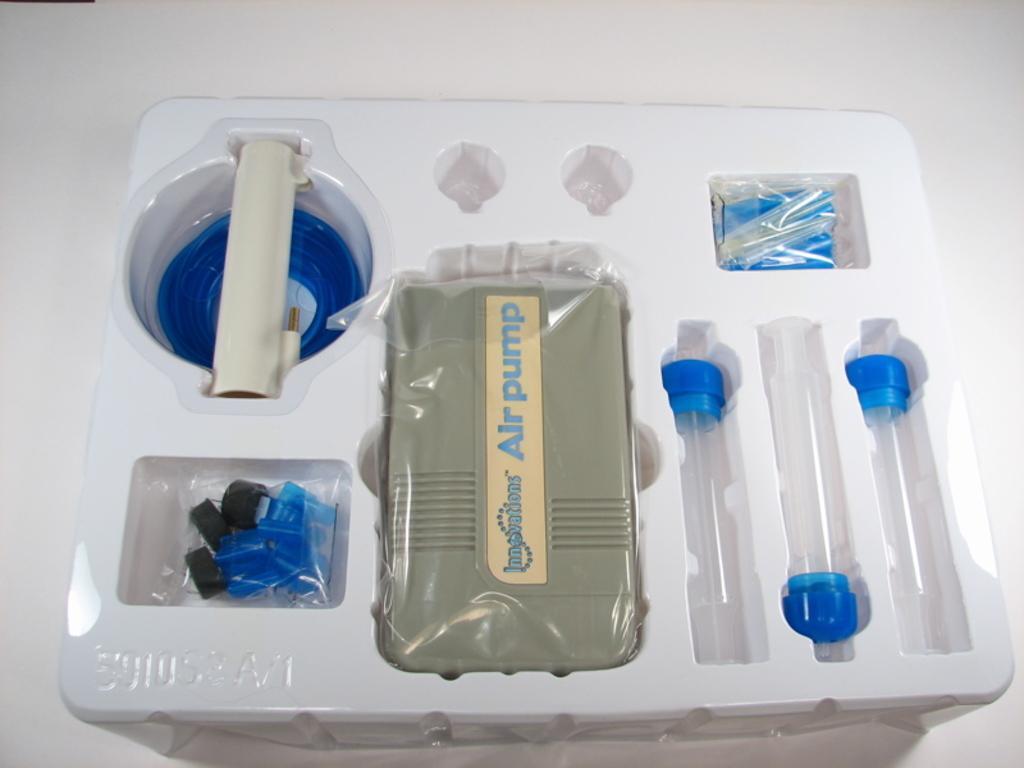In one or two sentences, can you explain what this image depicts? In this picture we can see a white plastic box with many things in it. 